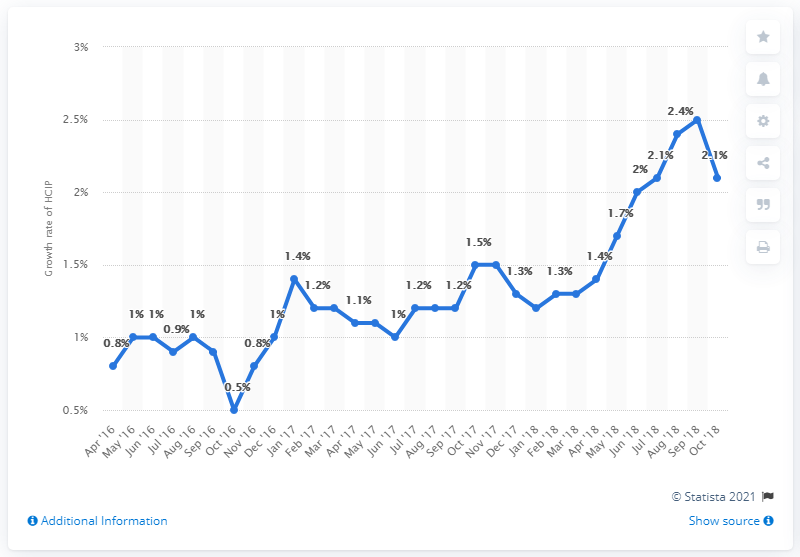Draw attention to some important aspects in this diagram. The inflation rate in March 2017 was 1.2%. 